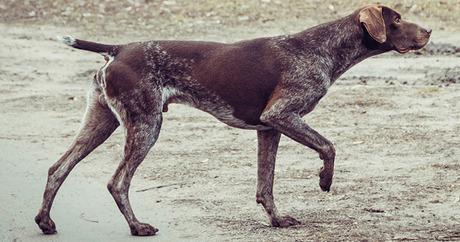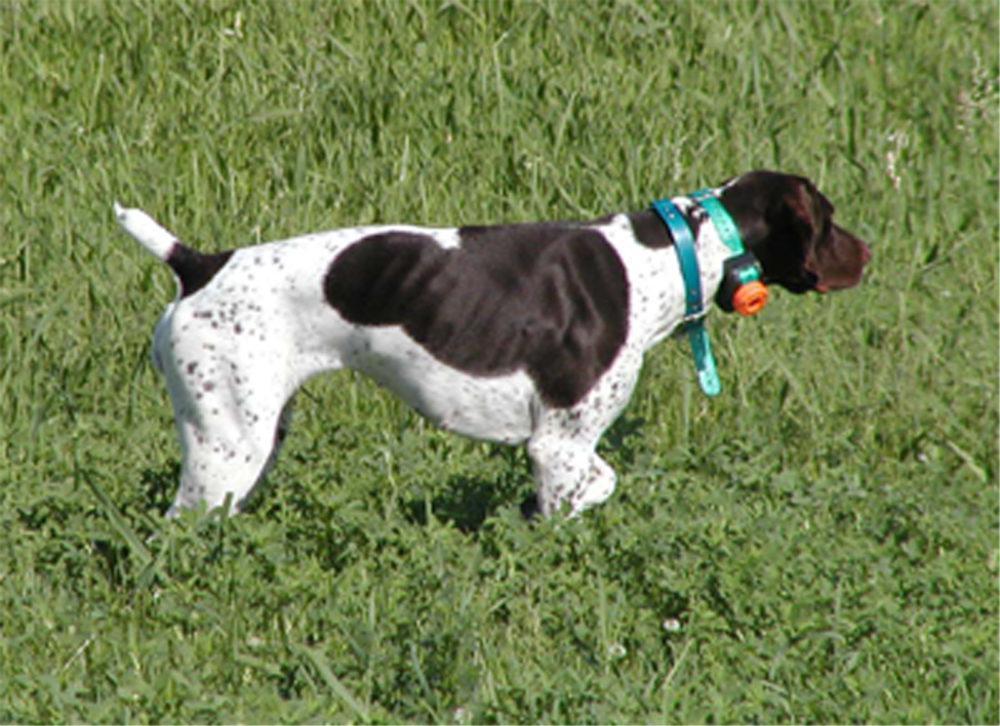The first image is the image on the left, the second image is the image on the right. Examine the images to the left and right. Is the description "The dogs in both images are wearing collars." accurate? Answer yes or no. No. The first image is the image on the left, the second image is the image on the right. Assess this claim about the two images: "In one of the images, there is a dog wearing an orange collar.". Correct or not? Answer yes or no. No. 